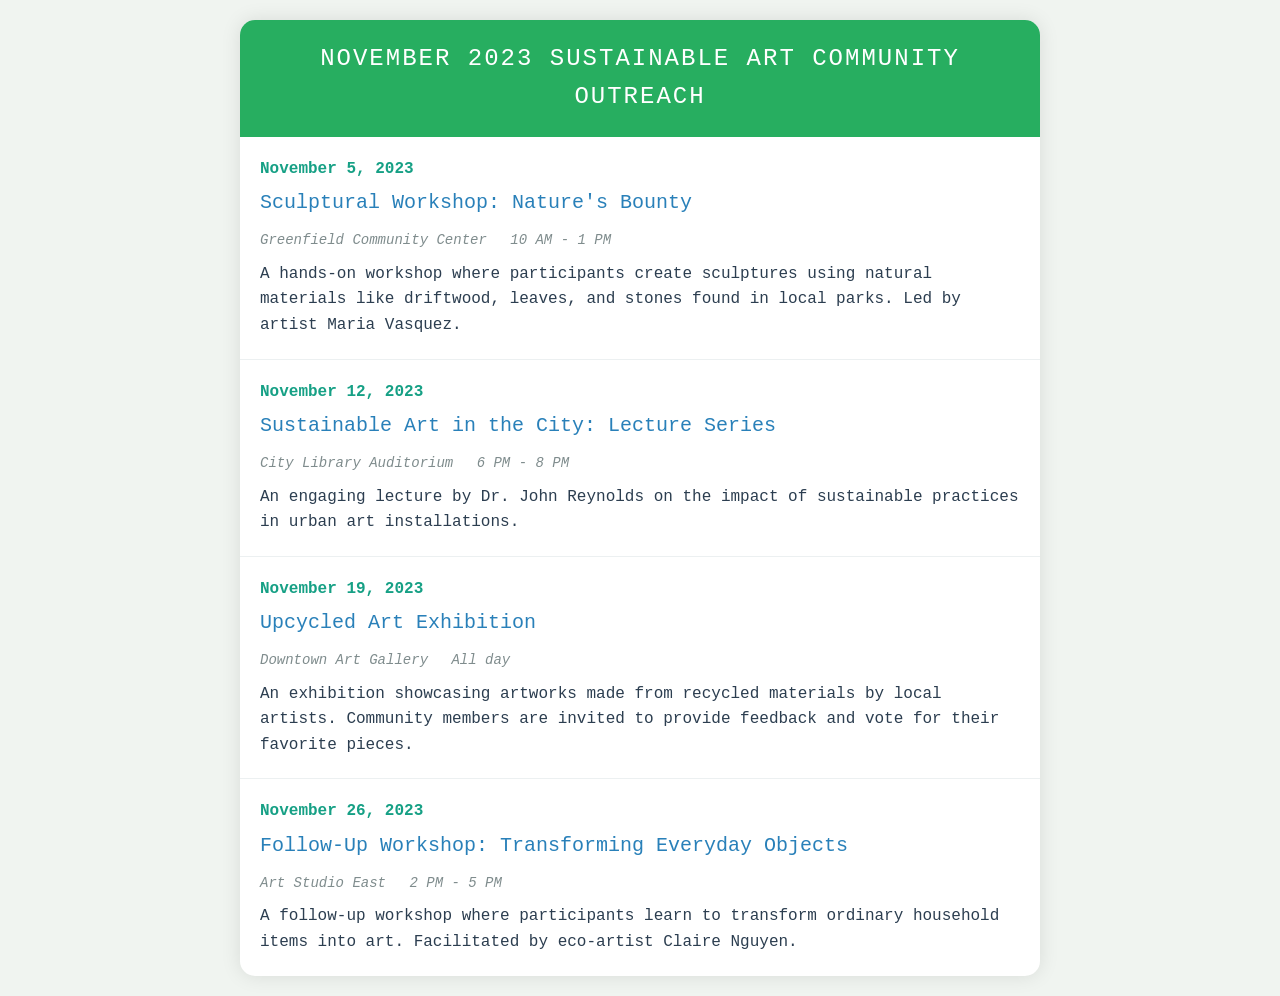What is the date of the Sculptural Workshop? The date of the Sculptural Workshop is mentioned in the document as November 5, 2023.
Answer: November 5, 2023 Where is the Sustainable Art in the City lecture held? The document specifies that the Sustainable Art in the City lecture is held at the City Library Auditorium.
Answer: City Library Auditorium Who is the artist leading the Sculptural Workshop? The document provides the name of the artist leading the Sculptural Workshop, which is Maria Vasquez.
Answer: Maria Vasquez What time does the Upcycled Art Exhibition last? The document states that the Upcycled Art Exhibition lasts all day, indicating there is no specific time.
Answer: All day How many total events are listed in the document? The document lists a total of four events in November 2023.
Answer: Four What is the focus of the Follow-Up Workshop? The Follow-Up Workshop focuses on transforming ordinary household items into art, as described in the document.
Answer: Transforming everyday objects What is the duration of the Sustainable Art in the City lecture? The document mentions that the duration of the Sustainable Art in the City lecture is from 6 PM to 8 PM.
Answer: 6 PM - 8 PM Which community center hosts the Sculptural Workshop? The name of the venue hosting the Sculptural Workshop is specified in the document as Greenfield Community Center.
Answer: Greenfield Community Center What type of materials are used in the Sculptural Workshop? The document details that natural materials like driftwood, leaves, and stones are used in the Sculptural Workshop.
Answer: Natural materials 